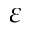<formula> <loc_0><loc_0><loc_500><loc_500>\varepsilon</formula> 